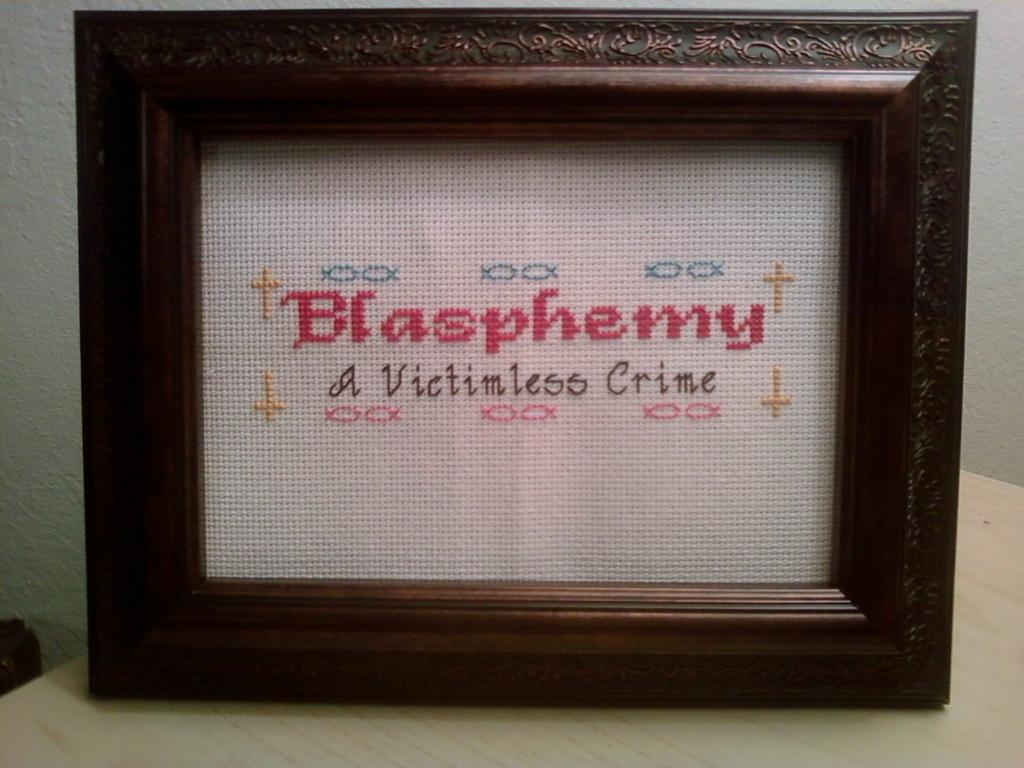Provide a one-sentence caption for the provided image. A framed needlepoint reading Blasphemy a victimless crime. 